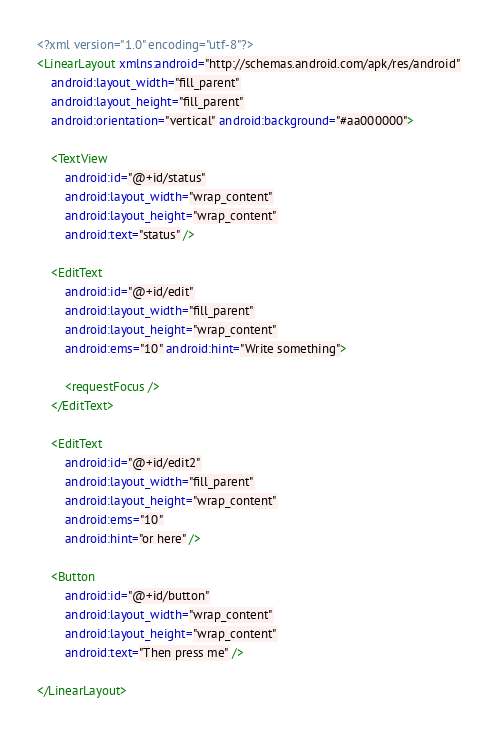Convert code to text. <code><loc_0><loc_0><loc_500><loc_500><_XML_><?xml version="1.0" encoding="utf-8"?>
<LinearLayout xmlns:android="http://schemas.android.com/apk/res/android"
    android:layout_width="fill_parent"
    android:layout_height="fill_parent"
    android:orientation="vertical" android:background="#aa000000">

    <TextView
        android:id="@+id/status"
        android:layout_width="wrap_content"
        android:layout_height="wrap_content"
        android:text="status" />

    <EditText
        android:id="@+id/edit"
        android:layout_width="fill_parent"
        android:layout_height="wrap_content"
        android:ems="10" android:hint="Write something">

        <requestFocus />
    </EditText>

    <EditText
        android:id="@+id/edit2"
        android:layout_width="fill_parent"
        android:layout_height="wrap_content"
        android:ems="10"
        android:hint="or here" />

    <Button
        android:id="@+id/button"
        android:layout_width="wrap_content"
        android:layout_height="wrap_content"
        android:text="Then press me" />

</LinearLayout></code> 